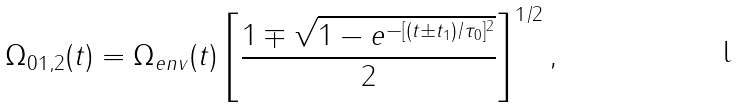<formula> <loc_0><loc_0><loc_500><loc_500>\Omega _ { 0 1 , 2 } ( t ) = \Omega _ { e n v } ( t ) \left [ \frac { 1 \mp \sqrt { 1 - e ^ { - [ ( t \pm t _ { 1 } ) / \tau _ { 0 } ] ^ { 2 } } } } { 2 } \right ] ^ { 1 / 2 } ,</formula> 